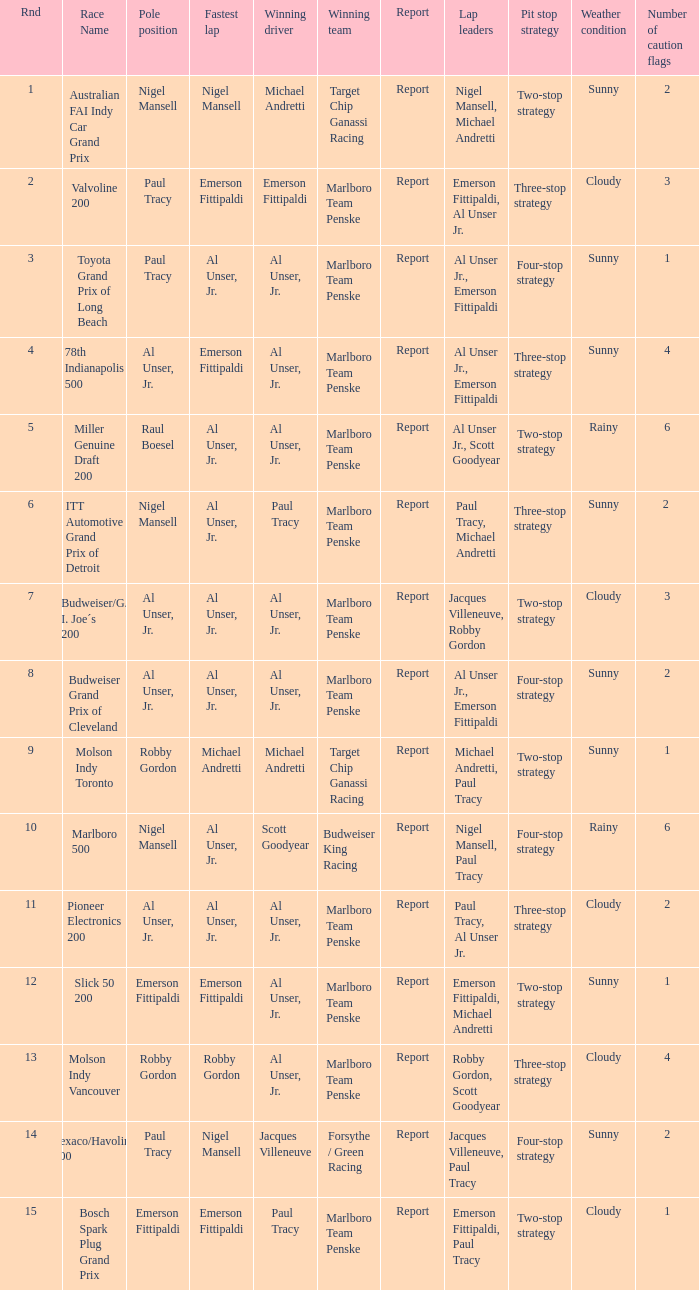Who was on the pole position in the Texaco/Havoline 200 race? Paul Tracy. 